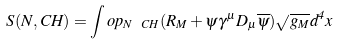<formula> <loc_0><loc_0><loc_500><loc_500>S ( N , C H ) = \int o p _ { N \ C H } ( R _ { M } + \psi \gamma ^ { \mu } D _ { \mu } \overline { \psi } ) \sqrt { g _ { M } } d ^ { 4 } x</formula> 